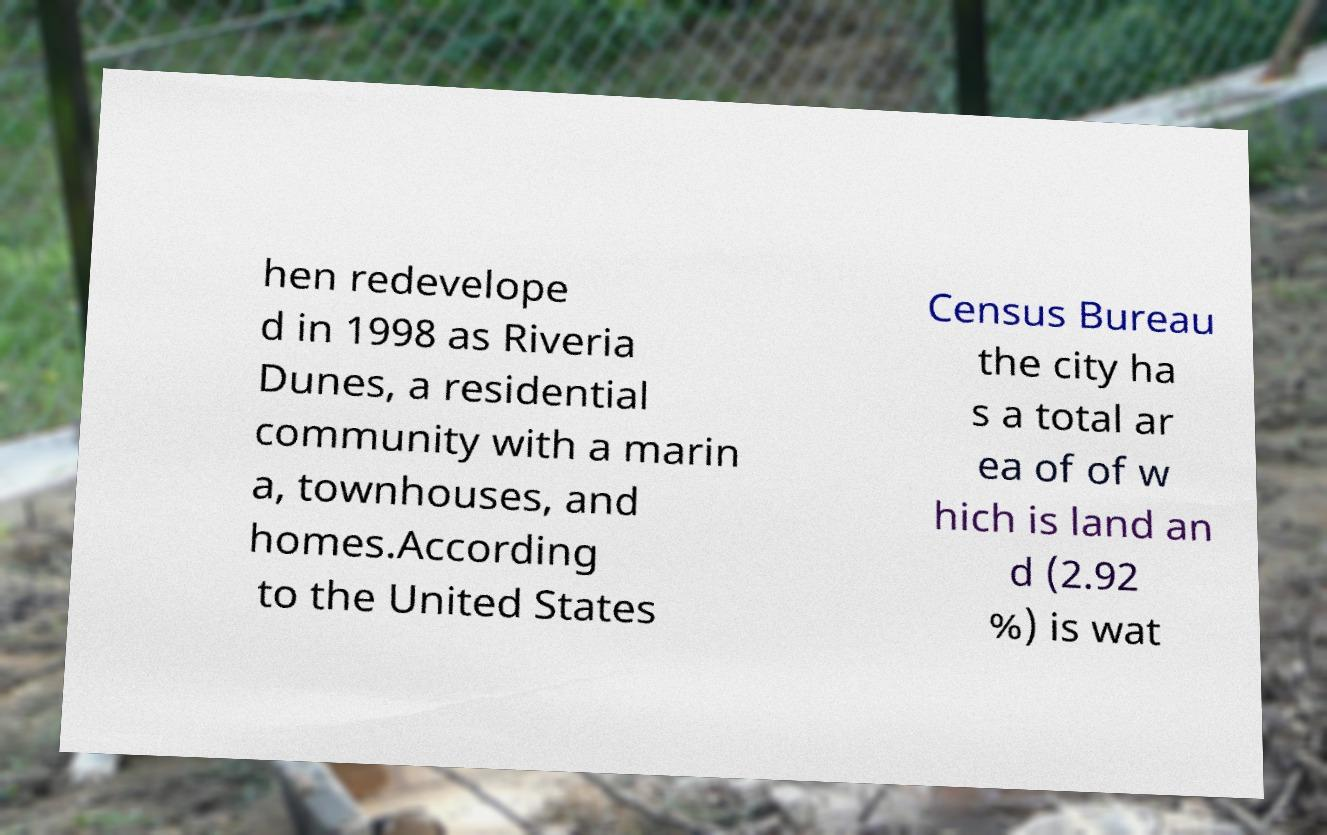Could you assist in decoding the text presented in this image and type it out clearly? hen redevelope d in 1998 as Riveria Dunes, a residential community with a marin a, townhouses, and homes.According to the United States Census Bureau the city ha s a total ar ea of of w hich is land an d (2.92 %) is wat 